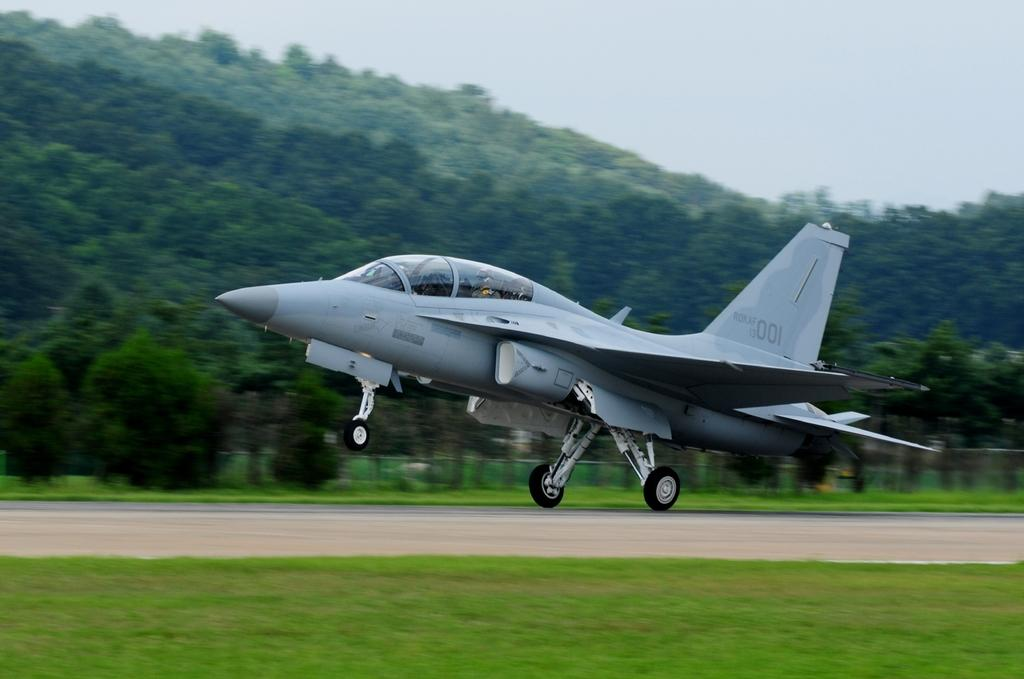<image>
Provide a brief description of the given image. The number 001 is on the tail of a military plane. 